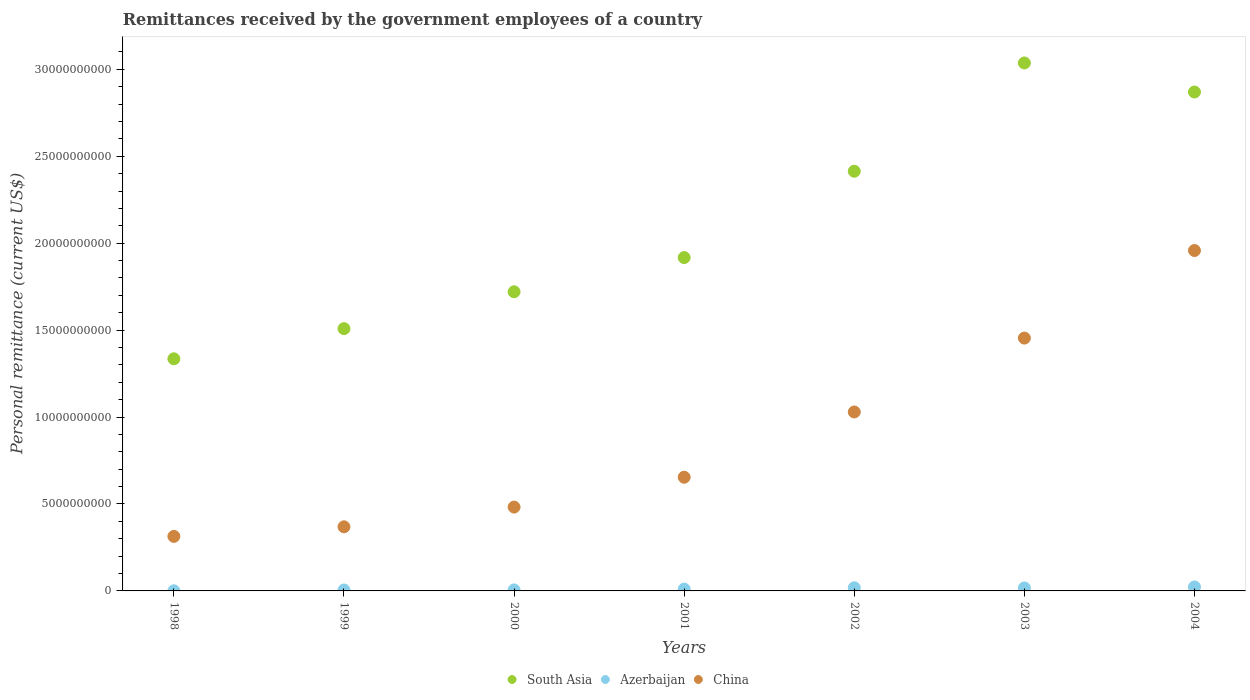How many different coloured dotlines are there?
Your answer should be very brief. 3. Is the number of dotlines equal to the number of legend labels?
Make the answer very short. Yes. What is the remittances received by the government employees in China in 1998?
Offer a terse response. 3.14e+09. Across all years, what is the maximum remittances received by the government employees in China?
Your response must be concise. 1.96e+1. Across all years, what is the minimum remittances received by the government employees in China?
Offer a terse response. 3.14e+09. In which year was the remittances received by the government employees in South Asia maximum?
Give a very brief answer. 2003. What is the total remittances received by the government employees in Azerbaijan in the graph?
Provide a short and direct response. 8.02e+08. What is the difference between the remittances received by the government employees in Azerbaijan in 1999 and that in 2004?
Give a very brief answer. -1.73e+08. What is the difference between the remittances received by the government employees in South Asia in 2003 and the remittances received by the government employees in Azerbaijan in 2000?
Keep it short and to the point. 3.03e+1. What is the average remittances received by the government employees in China per year?
Make the answer very short. 8.94e+09. In the year 2001, what is the difference between the remittances received by the government employees in Azerbaijan and remittances received by the government employees in China?
Provide a short and direct response. -6.43e+09. What is the ratio of the remittances received by the government employees in Azerbaijan in 1998 to that in 1999?
Your response must be concise. 0.12. Is the remittances received by the government employees in Azerbaijan in 2002 less than that in 2004?
Your answer should be very brief. Yes. What is the difference between the highest and the second highest remittances received by the government employees in China?
Your response must be concise. 5.04e+09. What is the difference between the highest and the lowest remittances received by the government employees in Azerbaijan?
Offer a very short reply. 2.21e+08. In how many years, is the remittances received by the government employees in South Asia greater than the average remittances received by the government employees in South Asia taken over all years?
Ensure brevity in your answer.  3. Is the remittances received by the government employees in China strictly less than the remittances received by the government employees in Azerbaijan over the years?
Offer a very short reply. No. How many dotlines are there?
Provide a succinct answer. 3. How many years are there in the graph?
Your response must be concise. 7. What is the difference between two consecutive major ticks on the Y-axis?
Provide a succinct answer. 5.00e+09. Does the graph contain grids?
Make the answer very short. No. Where does the legend appear in the graph?
Offer a very short reply. Bottom center. How many legend labels are there?
Provide a short and direct response. 3. How are the legend labels stacked?
Offer a very short reply. Horizontal. What is the title of the graph?
Keep it short and to the point. Remittances received by the government employees of a country. What is the label or title of the Y-axis?
Offer a very short reply. Personal remittance (current US$). What is the Personal remittance (current US$) in South Asia in 1998?
Give a very brief answer. 1.34e+1. What is the Personal remittance (current US$) in Azerbaijan in 1998?
Your answer should be very brief. 6.29e+06. What is the Personal remittance (current US$) of China in 1998?
Offer a terse response. 3.14e+09. What is the Personal remittance (current US$) of South Asia in 1999?
Offer a very short reply. 1.51e+1. What is the Personal remittance (current US$) of Azerbaijan in 1999?
Offer a very short reply. 5.45e+07. What is the Personal remittance (current US$) in China in 1999?
Your answer should be very brief. 3.69e+09. What is the Personal remittance (current US$) of South Asia in 2000?
Offer a very short reply. 1.72e+1. What is the Personal remittance (current US$) of Azerbaijan in 2000?
Make the answer very short. 5.71e+07. What is the Personal remittance (current US$) in China in 2000?
Provide a succinct answer. 4.82e+09. What is the Personal remittance (current US$) in South Asia in 2001?
Offer a very short reply. 1.92e+1. What is the Personal remittance (current US$) in Azerbaijan in 2001?
Give a very brief answer. 1.04e+08. What is the Personal remittance (current US$) of China in 2001?
Your answer should be compact. 6.54e+09. What is the Personal remittance (current US$) of South Asia in 2002?
Make the answer very short. 2.41e+1. What is the Personal remittance (current US$) of Azerbaijan in 2002?
Make the answer very short. 1.82e+08. What is the Personal remittance (current US$) of China in 2002?
Ensure brevity in your answer.  1.03e+1. What is the Personal remittance (current US$) of South Asia in 2003?
Make the answer very short. 3.04e+1. What is the Personal remittance (current US$) in Azerbaijan in 2003?
Provide a succinct answer. 1.71e+08. What is the Personal remittance (current US$) in China in 2003?
Provide a succinct answer. 1.45e+1. What is the Personal remittance (current US$) in South Asia in 2004?
Your answer should be very brief. 2.87e+1. What is the Personal remittance (current US$) of Azerbaijan in 2004?
Give a very brief answer. 2.28e+08. What is the Personal remittance (current US$) of China in 2004?
Your answer should be very brief. 1.96e+1. Across all years, what is the maximum Personal remittance (current US$) in South Asia?
Offer a terse response. 3.04e+1. Across all years, what is the maximum Personal remittance (current US$) in Azerbaijan?
Provide a succinct answer. 2.28e+08. Across all years, what is the maximum Personal remittance (current US$) of China?
Keep it short and to the point. 1.96e+1. Across all years, what is the minimum Personal remittance (current US$) in South Asia?
Ensure brevity in your answer.  1.34e+1. Across all years, what is the minimum Personal remittance (current US$) of Azerbaijan?
Offer a terse response. 6.29e+06. Across all years, what is the minimum Personal remittance (current US$) in China?
Provide a succinct answer. 3.14e+09. What is the total Personal remittance (current US$) of South Asia in the graph?
Offer a very short reply. 1.48e+11. What is the total Personal remittance (current US$) in Azerbaijan in the graph?
Keep it short and to the point. 8.02e+08. What is the total Personal remittance (current US$) in China in the graph?
Offer a terse response. 6.26e+1. What is the difference between the Personal remittance (current US$) in South Asia in 1998 and that in 1999?
Make the answer very short. -1.73e+09. What is the difference between the Personal remittance (current US$) in Azerbaijan in 1998 and that in 1999?
Make the answer very short. -4.82e+07. What is the difference between the Personal remittance (current US$) in China in 1998 and that in 1999?
Give a very brief answer. -5.50e+08. What is the difference between the Personal remittance (current US$) in South Asia in 1998 and that in 2000?
Your answer should be very brief. -3.85e+09. What is the difference between the Personal remittance (current US$) in Azerbaijan in 1998 and that in 2000?
Ensure brevity in your answer.  -5.08e+07. What is the difference between the Personal remittance (current US$) in China in 1998 and that in 2000?
Offer a terse response. -1.69e+09. What is the difference between the Personal remittance (current US$) of South Asia in 1998 and that in 2001?
Make the answer very short. -5.82e+09. What is the difference between the Personal remittance (current US$) of Azerbaijan in 1998 and that in 2001?
Your response must be concise. -9.78e+07. What is the difference between the Personal remittance (current US$) in China in 1998 and that in 2001?
Provide a short and direct response. -3.40e+09. What is the difference between the Personal remittance (current US$) of South Asia in 1998 and that in 2002?
Keep it short and to the point. -1.08e+1. What is the difference between the Personal remittance (current US$) of Azerbaijan in 1998 and that in 2002?
Give a very brief answer. -1.75e+08. What is the difference between the Personal remittance (current US$) in China in 1998 and that in 2002?
Ensure brevity in your answer.  -7.16e+09. What is the difference between the Personal remittance (current US$) of South Asia in 1998 and that in 2003?
Provide a succinct answer. -1.70e+1. What is the difference between the Personal remittance (current US$) of Azerbaijan in 1998 and that in 2003?
Keep it short and to the point. -1.65e+08. What is the difference between the Personal remittance (current US$) in China in 1998 and that in 2003?
Your answer should be very brief. -1.14e+1. What is the difference between the Personal remittance (current US$) of South Asia in 1998 and that in 2004?
Ensure brevity in your answer.  -1.53e+1. What is the difference between the Personal remittance (current US$) in Azerbaijan in 1998 and that in 2004?
Offer a terse response. -2.21e+08. What is the difference between the Personal remittance (current US$) in China in 1998 and that in 2004?
Offer a very short reply. -1.64e+1. What is the difference between the Personal remittance (current US$) in South Asia in 1999 and that in 2000?
Your response must be concise. -2.12e+09. What is the difference between the Personal remittance (current US$) of Azerbaijan in 1999 and that in 2000?
Provide a short and direct response. -2.64e+06. What is the difference between the Personal remittance (current US$) of China in 1999 and that in 2000?
Make the answer very short. -1.14e+09. What is the difference between the Personal remittance (current US$) of South Asia in 1999 and that in 2001?
Your response must be concise. -4.09e+09. What is the difference between the Personal remittance (current US$) in Azerbaijan in 1999 and that in 2001?
Your answer should be very brief. -4.96e+07. What is the difference between the Personal remittance (current US$) of China in 1999 and that in 2001?
Make the answer very short. -2.85e+09. What is the difference between the Personal remittance (current US$) of South Asia in 1999 and that in 2002?
Your answer should be very brief. -9.05e+09. What is the difference between the Personal remittance (current US$) in Azerbaijan in 1999 and that in 2002?
Keep it short and to the point. -1.27e+08. What is the difference between the Personal remittance (current US$) in China in 1999 and that in 2002?
Ensure brevity in your answer.  -6.61e+09. What is the difference between the Personal remittance (current US$) of South Asia in 1999 and that in 2003?
Keep it short and to the point. -1.53e+1. What is the difference between the Personal remittance (current US$) of Azerbaijan in 1999 and that in 2003?
Make the answer very short. -1.16e+08. What is the difference between the Personal remittance (current US$) of China in 1999 and that in 2003?
Give a very brief answer. -1.09e+1. What is the difference between the Personal remittance (current US$) of South Asia in 1999 and that in 2004?
Provide a succinct answer. -1.36e+1. What is the difference between the Personal remittance (current US$) in Azerbaijan in 1999 and that in 2004?
Make the answer very short. -1.73e+08. What is the difference between the Personal remittance (current US$) of China in 1999 and that in 2004?
Offer a terse response. -1.59e+1. What is the difference between the Personal remittance (current US$) of South Asia in 2000 and that in 2001?
Ensure brevity in your answer.  -1.97e+09. What is the difference between the Personal remittance (current US$) of Azerbaijan in 2000 and that in 2001?
Offer a terse response. -4.70e+07. What is the difference between the Personal remittance (current US$) in China in 2000 and that in 2001?
Provide a succinct answer. -1.72e+09. What is the difference between the Personal remittance (current US$) of South Asia in 2000 and that in 2002?
Ensure brevity in your answer.  -6.93e+09. What is the difference between the Personal remittance (current US$) of Azerbaijan in 2000 and that in 2002?
Your response must be concise. -1.25e+08. What is the difference between the Personal remittance (current US$) in China in 2000 and that in 2002?
Keep it short and to the point. -5.47e+09. What is the difference between the Personal remittance (current US$) in South Asia in 2000 and that in 2003?
Your answer should be compact. -1.32e+1. What is the difference between the Personal remittance (current US$) in Azerbaijan in 2000 and that in 2003?
Give a very brief answer. -1.14e+08. What is the difference between the Personal remittance (current US$) in China in 2000 and that in 2003?
Keep it short and to the point. -9.72e+09. What is the difference between the Personal remittance (current US$) of South Asia in 2000 and that in 2004?
Provide a short and direct response. -1.15e+1. What is the difference between the Personal remittance (current US$) of Azerbaijan in 2000 and that in 2004?
Offer a very short reply. -1.70e+08. What is the difference between the Personal remittance (current US$) in China in 2000 and that in 2004?
Offer a very short reply. -1.48e+1. What is the difference between the Personal remittance (current US$) in South Asia in 2001 and that in 2002?
Offer a very short reply. -4.97e+09. What is the difference between the Personal remittance (current US$) in Azerbaijan in 2001 and that in 2002?
Keep it short and to the point. -7.76e+07. What is the difference between the Personal remittance (current US$) of China in 2001 and that in 2002?
Offer a very short reply. -3.75e+09. What is the difference between the Personal remittance (current US$) in South Asia in 2001 and that in 2003?
Give a very brief answer. -1.12e+1. What is the difference between the Personal remittance (current US$) in Azerbaijan in 2001 and that in 2003?
Your answer should be compact. -6.68e+07. What is the difference between the Personal remittance (current US$) in China in 2001 and that in 2003?
Make the answer very short. -8.00e+09. What is the difference between the Personal remittance (current US$) of South Asia in 2001 and that in 2004?
Your answer should be very brief. -9.52e+09. What is the difference between the Personal remittance (current US$) in Azerbaijan in 2001 and that in 2004?
Your response must be concise. -1.23e+08. What is the difference between the Personal remittance (current US$) of China in 2001 and that in 2004?
Provide a succinct answer. -1.30e+1. What is the difference between the Personal remittance (current US$) of South Asia in 2002 and that in 2003?
Make the answer very short. -6.23e+09. What is the difference between the Personal remittance (current US$) in Azerbaijan in 2002 and that in 2003?
Ensure brevity in your answer.  1.08e+07. What is the difference between the Personal remittance (current US$) of China in 2002 and that in 2003?
Ensure brevity in your answer.  -4.25e+09. What is the difference between the Personal remittance (current US$) of South Asia in 2002 and that in 2004?
Offer a very short reply. -4.56e+09. What is the difference between the Personal remittance (current US$) in Azerbaijan in 2002 and that in 2004?
Provide a succinct answer. -4.59e+07. What is the difference between the Personal remittance (current US$) of China in 2002 and that in 2004?
Provide a short and direct response. -9.29e+09. What is the difference between the Personal remittance (current US$) of South Asia in 2003 and that in 2004?
Give a very brief answer. 1.67e+09. What is the difference between the Personal remittance (current US$) in Azerbaijan in 2003 and that in 2004?
Keep it short and to the point. -5.66e+07. What is the difference between the Personal remittance (current US$) in China in 2003 and that in 2004?
Make the answer very short. -5.04e+09. What is the difference between the Personal remittance (current US$) of South Asia in 1998 and the Personal remittance (current US$) of Azerbaijan in 1999?
Offer a very short reply. 1.33e+1. What is the difference between the Personal remittance (current US$) in South Asia in 1998 and the Personal remittance (current US$) in China in 1999?
Your answer should be compact. 9.66e+09. What is the difference between the Personal remittance (current US$) of Azerbaijan in 1998 and the Personal remittance (current US$) of China in 1999?
Offer a terse response. -3.68e+09. What is the difference between the Personal remittance (current US$) in South Asia in 1998 and the Personal remittance (current US$) in Azerbaijan in 2000?
Offer a terse response. 1.33e+1. What is the difference between the Personal remittance (current US$) in South Asia in 1998 and the Personal remittance (current US$) in China in 2000?
Your answer should be very brief. 8.53e+09. What is the difference between the Personal remittance (current US$) of Azerbaijan in 1998 and the Personal remittance (current US$) of China in 2000?
Give a very brief answer. -4.82e+09. What is the difference between the Personal remittance (current US$) in South Asia in 1998 and the Personal remittance (current US$) in Azerbaijan in 2001?
Offer a terse response. 1.32e+1. What is the difference between the Personal remittance (current US$) of South Asia in 1998 and the Personal remittance (current US$) of China in 2001?
Give a very brief answer. 6.81e+09. What is the difference between the Personal remittance (current US$) of Azerbaijan in 1998 and the Personal remittance (current US$) of China in 2001?
Ensure brevity in your answer.  -6.53e+09. What is the difference between the Personal remittance (current US$) of South Asia in 1998 and the Personal remittance (current US$) of Azerbaijan in 2002?
Keep it short and to the point. 1.32e+1. What is the difference between the Personal remittance (current US$) of South Asia in 1998 and the Personal remittance (current US$) of China in 2002?
Offer a very short reply. 3.06e+09. What is the difference between the Personal remittance (current US$) of Azerbaijan in 1998 and the Personal remittance (current US$) of China in 2002?
Keep it short and to the point. -1.03e+1. What is the difference between the Personal remittance (current US$) in South Asia in 1998 and the Personal remittance (current US$) in Azerbaijan in 2003?
Ensure brevity in your answer.  1.32e+1. What is the difference between the Personal remittance (current US$) in South Asia in 1998 and the Personal remittance (current US$) in China in 2003?
Your answer should be compact. -1.19e+09. What is the difference between the Personal remittance (current US$) of Azerbaijan in 1998 and the Personal remittance (current US$) of China in 2003?
Provide a succinct answer. -1.45e+1. What is the difference between the Personal remittance (current US$) in South Asia in 1998 and the Personal remittance (current US$) in Azerbaijan in 2004?
Offer a terse response. 1.31e+1. What is the difference between the Personal remittance (current US$) of South Asia in 1998 and the Personal remittance (current US$) of China in 2004?
Your answer should be compact. -6.23e+09. What is the difference between the Personal remittance (current US$) in Azerbaijan in 1998 and the Personal remittance (current US$) in China in 2004?
Your response must be concise. -1.96e+1. What is the difference between the Personal remittance (current US$) of South Asia in 1999 and the Personal remittance (current US$) of Azerbaijan in 2000?
Your response must be concise. 1.50e+1. What is the difference between the Personal remittance (current US$) of South Asia in 1999 and the Personal remittance (current US$) of China in 2000?
Offer a terse response. 1.03e+1. What is the difference between the Personal remittance (current US$) of Azerbaijan in 1999 and the Personal remittance (current US$) of China in 2000?
Your answer should be compact. -4.77e+09. What is the difference between the Personal remittance (current US$) in South Asia in 1999 and the Personal remittance (current US$) in Azerbaijan in 2001?
Provide a succinct answer. 1.50e+1. What is the difference between the Personal remittance (current US$) in South Asia in 1999 and the Personal remittance (current US$) in China in 2001?
Provide a short and direct response. 8.55e+09. What is the difference between the Personal remittance (current US$) of Azerbaijan in 1999 and the Personal remittance (current US$) of China in 2001?
Offer a very short reply. -6.48e+09. What is the difference between the Personal remittance (current US$) of South Asia in 1999 and the Personal remittance (current US$) of Azerbaijan in 2002?
Make the answer very short. 1.49e+1. What is the difference between the Personal remittance (current US$) of South Asia in 1999 and the Personal remittance (current US$) of China in 2002?
Make the answer very short. 4.79e+09. What is the difference between the Personal remittance (current US$) in Azerbaijan in 1999 and the Personal remittance (current US$) in China in 2002?
Your answer should be very brief. -1.02e+1. What is the difference between the Personal remittance (current US$) in South Asia in 1999 and the Personal remittance (current US$) in Azerbaijan in 2003?
Keep it short and to the point. 1.49e+1. What is the difference between the Personal remittance (current US$) in South Asia in 1999 and the Personal remittance (current US$) in China in 2003?
Keep it short and to the point. 5.43e+08. What is the difference between the Personal remittance (current US$) in Azerbaijan in 1999 and the Personal remittance (current US$) in China in 2003?
Keep it short and to the point. -1.45e+1. What is the difference between the Personal remittance (current US$) of South Asia in 1999 and the Personal remittance (current US$) of Azerbaijan in 2004?
Ensure brevity in your answer.  1.49e+1. What is the difference between the Personal remittance (current US$) of South Asia in 1999 and the Personal remittance (current US$) of China in 2004?
Ensure brevity in your answer.  -4.49e+09. What is the difference between the Personal remittance (current US$) in Azerbaijan in 1999 and the Personal remittance (current US$) in China in 2004?
Offer a very short reply. -1.95e+1. What is the difference between the Personal remittance (current US$) in South Asia in 2000 and the Personal remittance (current US$) in Azerbaijan in 2001?
Your answer should be very brief. 1.71e+1. What is the difference between the Personal remittance (current US$) of South Asia in 2000 and the Personal remittance (current US$) of China in 2001?
Your answer should be very brief. 1.07e+1. What is the difference between the Personal remittance (current US$) of Azerbaijan in 2000 and the Personal remittance (current US$) of China in 2001?
Provide a succinct answer. -6.48e+09. What is the difference between the Personal remittance (current US$) in South Asia in 2000 and the Personal remittance (current US$) in Azerbaijan in 2002?
Ensure brevity in your answer.  1.70e+1. What is the difference between the Personal remittance (current US$) in South Asia in 2000 and the Personal remittance (current US$) in China in 2002?
Provide a short and direct response. 6.91e+09. What is the difference between the Personal remittance (current US$) of Azerbaijan in 2000 and the Personal remittance (current US$) of China in 2002?
Provide a succinct answer. -1.02e+1. What is the difference between the Personal remittance (current US$) in South Asia in 2000 and the Personal remittance (current US$) in Azerbaijan in 2003?
Ensure brevity in your answer.  1.70e+1. What is the difference between the Personal remittance (current US$) of South Asia in 2000 and the Personal remittance (current US$) of China in 2003?
Give a very brief answer. 2.66e+09. What is the difference between the Personal remittance (current US$) of Azerbaijan in 2000 and the Personal remittance (current US$) of China in 2003?
Provide a succinct answer. -1.45e+1. What is the difference between the Personal remittance (current US$) in South Asia in 2000 and the Personal remittance (current US$) in Azerbaijan in 2004?
Offer a very short reply. 1.70e+1. What is the difference between the Personal remittance (current US$) in South Asia in 2000 and the Personal remittance (current US$) in China in 2004?
Make the answer very short. -2.37e+09. What is the difference between the Personal remittance (current US$) in Azerbaijan in 2000 and the Personal remittance (current US$) in China in 2004?
Make the answer very short. -1.95e+1. What is the difference between the Personal remittance (current US$) in South Asia in 2001 and the Personal remittance (current US$) in Azerbaijan in 2002?
Provide a succinct answer. 1.90e+1. What is the difference between the Personal remittance (current US$) of South Asia in 2001 and the Personal remittance (current US$) of China in 2002?
Your response must be concise. 8.88e+09. What is the difference between the Personal remittance (current US$) in Azerbaijan in 2001 and the Personal remittance (current US$) in China in 2002?
Your answer should be compact. -1.02e+1. What is the difference between the Personal remittance (current US$) of South Asia in 2001 and the Personal remittance (current US$) of Azerbaijan in 2003?
Your response must be concise. 1.90e+1. What is the difference between the Personal remittance (current US$) in South Asia in 2001 and the Personal remittance (current US$) in China in 2003?
Provide a succinct answer. 4.63e+09. What is the difference between the Personal remittance (current US$) in Azerbaijan in 2001 and the Personal remittance (current US$) in China in 2003?
Offer a terse response. -1.44e+1. What is the difference between the Personal remittance (current US$) in South Asia in 2001 and the Personal remittance (current US$) in Azerbaijan in 2004?
Keep it short and to the point. 1.89e+1. What is the difference between the Personal remittance (current US$) in South Asia in 2001 and the Personal remittance (current US$) in China in 2004?
Keep it short and to the point. -4.06e+08. What is the difference between the Personal remittance (current US$) of Azerbaijan in 2001 and the Personal remittance (current US$) of China in 2004?
Provide a succinct answer. -1.95e+1. What is the difference between the Personal remittance (current US$) in South Asia in 2002 and the Personal remittance (current US$) in Azerbaijan in 2003?
Offer a terse response. 2.40e+1. What is the difference between the Personal remittance (current US$) of South Asia in 2002 and the Personal remittance (current US$) of China in 2003?
Make the answer very short. 9.59e+09. What is the difference between the Personal remittance (current US$) in Azerbaijan in 2002 and the Personal remittance (current US$) in China in 2003?
Your answer should be very brief. -1.44e+1. What is the difference between the Personal remittance (current US$) in South Asia in 2002 and the Personal remittance (current US$) in Azerbaijan in 2004?
Ensure brevity in your answer.  2.39e+1. What is the difference between the Personal remittance (current US$) in South Asia in 2002 and the Personal remittance (current US$) in China in 2004?
Your answer should be compact. 4.56e+09. What is the difference between the Personal remittance (current US$) of Azerbaijan in 2002 and the Personal remittance (current US$) of China in 2004?
Your answer should be compact. -1.94e+1. What is the difference between the Personal remittance (current US$) in South Asia in 2003 and the Personal remittance (current US$) in Azerbaijan in 2004?
Make the answer very short. 3.01e+1. What is the difference between the Personal remittance (current US$) in South Asia in 2003 and the Personal remittance (current US$) in China in 2004?
Your response must be concise. 1.08e+1. What is the difference between the Personal remittance (current US$) in Azerbaijan in 2003 and the Personal remittance (current US$) in China in 2004?
Your answer should be very brief. -1.94e+1. What is the average Personal remittance (current US$) in South Asia per year?
Provide a short and direct response. 2.11e+1. What is the average Personal remittance (current US$) in Azerbaijan per year?
Ensure brevity in your answer.  1.15e+08. What is the average Personal remittance (current US$) of China per year?
Provide a short and direct response. 8.94e+09. In the year 1998, what is the difference between the Personal remittance (current US$) in South Asia and Personal remittance (current US$) in Azerbaijan?
Provide a succinct answer. 1.33e+1. In the year 1998, what is the difference between the Personal remittance (current US$) in South Asia and Personal remittance (current US$) in China?
Keep it short and to the point. 1.02e+1. In the year 1998, what is the difference between the Personal remittance (current US$) in Azerbaijan and Personal remittance (current US$) in China?
Offer a terse response. -3.13e+09. In the year 1999, what is the difference between the Personal remittance (current US$) in South Asia and Personal remittance (current US$) in Azerbaijan?
Provide a succinct answer. 1.50e+1. In the year 1999, what is the difference between the Personal remittance (current US$) in South Asia and Personal remittance (current US$) in China?
Ensure brevity in your answer.  1.14e+1. In the year 1999, what is the difference between the Personal remittance (current US$) in Azerbaijan and Personal remittance (current US$) in China?
Provide a succinct answer. -3.63e+09. In the year 2000, what is the difference between the Personal remittance (current US$) of South Asia and Personal remittance (current US$) of Azerbaijan?
Give a very brief answer. 1.71e+1. In the year 2000, what is the difference between the Personal remittance (current US$) in South Asia and Personal remittance (current US$) in China?
Your answer should be compact. 1.24e+1. In the year 2000, what is the difference between the Personal remittance (current US$) in Azerbaijan and Personal remittance (current US$) in China?
Your answer should be compact. -4.76e+09. In the year 2001, what is the difference between the Personal remittance (current US$) in South Asia and Personal remittance (current US$) in Azerbaijan?
Ensure brevity in your answer.  1.91e+1. In the year 2001, what is the difference between the Personal remittance (current US$) in South Asia and Personal remittance (current US$) in China?
Make the answer very short. 1.26e+1. In the year 2001, what is the difference between the Personal remittance (current US$) in Azerbaijan and Personal remittance (current US$) in China?
Keep it short and to the point. -6.43e+09. In the year 2002, what is the difference between the Personal remittance (current US$) in South Asia and Personal remittance (current US$) in Azerbaijan?
Make the answer very short. 2.40e+1. In the year 2002, what is the difference between the Personal remittance (current US$) in South Asia and Personal remittance (current US$) in China?
Give a very brief answer. 1.38e+1. In the year 2002, what is the difference between the Personal remittance (current US$) in Azerbaijan and Personal remittance (current US$) in China?
Ensure brevity in your answer.  -1.01e+1. In the year 2003, what is the difference between the Personal remittance (current US$) of South Asia and Personal remittance (current US$) of Azerbaijan?
Provide a succinct answer. 3.02e+1. In the year 2003, what is the difference between the Personal remittance (current US$) of South Asia and Personal remittance (current US$) of China?
Offer a terse response. 1.58e+1. In the year 2003, what is the difference between the Personal remittance (current US$) of Azerbaijan and Personal remittance (current US$) of China?
Offer a terse response. -1.44e+1. In the year 2004, what is the difference between the Personal remittance (current US$) in South Asia and Personal remittance (current US$) in Azerbaijan?
Provide a succinct answer. 2.85e+1. In the year 2004, what is the difference between the Personal remittance (current US$) of South Asia and Personal remittance (current US$) of China?
Your answer should be compact. 9.12e+09. In the year 2004, what is the difference between the Personal remittance (current US$) in Azerbaijan and Personal remittance (current US$) in China?
Make the answer very short. -1.94e+1. What is the ratio of the Personal remittance (current US$) of South Asia in 1998 to that in 1999?
Offer a terse response. 0.89. What is the ratio of the Personal remittance (current US$) of Azerbaijan in 1998 to that in 1999?
Your response must be concise. 0.12. What is the ratio of the Personal remittance (current US$) of China in 1998 to that in 1999?
Ensure brevity in your answer.  0.85. What is the ratio of the Personal remittance (current US$) in South Asia in 1998 to that in 2000?
Give a very brief answer. 0.78. What is the ratio of the Personal remittance (current US$) in Azerbaijan in 1998 to that in 2000?
Your answer should be compact. 0.11. What is the ratio of the Personal remittance (current US$) in China in 1998 to that in 2000?
Your answer should be compact. 0.65. What is the ratio of the Personal remittance (current US$) of South Asia in 1998 to that in 2001?
Keep it short and to the point. 0.7. What is the ratio of the Personal remittance (current US$) in Azerbaijan in 1998 to that in 2001?
Make the answer very short. 0.06. What is the ratio of the Personal remittance (current US$) in China in 1998 to that in 2001?
Offer a very short reply. 0.48. What is the ratio of the Personal remittance (current US$) of South Asia in 1998 to that in 2002?
Offer a terse response. 0.55. What is the ratio of the Personal remittance (current US$) of Azerbaijan in 1998 to that in 2002?
Ensure brevity in your answer.  0.03. What is the ratio of the Personal remittance (current US$) in China in 1998 to that in 2002?
Provide a succinct answer. 0.3. What is the ratio of the Personal remittance (current US$) of South Asia in 1998 to that in 2003?
Keep it short and to the point. 0.44. What is the ratio of the Personal remittance (current US$) in Azerbaijan in 1998 to that in 2003?
Give a very brief answer. 0.04. What is the ratio of the Personal remittance (current US$) of China in 1998 to that in 2003?
Ensure brevity in your answer.  0.22. What is the ratio of the Personal remittance (current US$) in South Asia in 1998 to that in 2004?
Your answer should be compact. 0.47. What is the ratio of the Personal remittance (current US$) of Azerbaijan in 1998 to that in 2004?
Your answer should be compact. 0.03. What is the ratio of the Personal remittance (current US$) in China in 1998 to that in 2004?
Provide a short and direct response. 0.16. What is the ratio of the Personal remittance (current US$) in South Asia in 1999 to that in 2000?
Offer a terse response. 0.88. What is the ratio of the Personal remittance (current US$) of Azerbaijan in 1999 to that in 2000?
Your answer should be very brief. 0.95. What is the ratio of the Personal remittance (current US$) of China in 1999 to that in 2000?
Keep it short and to the point. 0.76. What is the ratio of the Personal remittance (current US$) of South Asia in 1999 to that in 2001?
Ensure brevity in your answer.  0.79. What is the ratio of the Personal remittance (current US$) of Azerbaijan in 1999 to that in 2001?
Your answer should be compact. 0.52. What is the ratio of the Personal remittance (current US$) of China in 1999 to that in 2001?
Your answer should be very brief. 0.56. What is the ratio of the Personal remittance (current US$) in South Asia in 1999 to that in 2002?
Your response must be concise. 0.62. What is the ratio of the Personal remittance (current US$) of Azerbaijan in 1999 to that in 2002?
Your answer should be compact. 0.3. What is the ratio of the Personal remittance (current US$) in China in 1999 to that in 2002?
Provide a succinct answer. 0.36. What is the ratio of the Personal remittance (current US$) in South Asia in 1999 to that in 2003?
Provide a short and direct response. 0.5. What is the ratio of the Personal remittance (current US$) in Azerbaijan in 1999 to that in 2003?
Your response must be concise. 0.32. What is the ratio of the Personal remittance (current US$) in China in 1999 to that in 2003?
Your answer should be compact. 0.25. What is the ratio of the Personal remittance (current US$) of South Asia in 1999 to that in 2004?
Provide a short and direct response. 0.53. What is the ratio of the Personal remittance (current US$) of Azerbaijan in 1999 to that in 2004?
Your answer should be compact. 0.24. What is the ratio of the Personal remittance (current US$) in China in 1999 to that in 2004?
Provide a succinct answer. 0.19. What is the ratio of the Personal remittance (current US$) in South Asia in 2000 to that in 2001?
Offer a very short reply. 0.9. What is the ratio of the Personal remittance (current US$) in Azerbaijan in 2000 to that in 2001?
Your answer should be compact. 0.55. What is the ratio of the Personal remittance (current US$) in China in 2000 to that in 2001?
Ensure brevity in your answer.  0.74. What is the ratio of the Personal remittance (current US$) of South Asia in 2000 to that in 2002?
Provide a short and direct response. 0.71. What is the ratio of the Personal remittance (current US$) of Azerbaijan in 2000 to that in 2002?
Give a very brief answer. 0.31. What is the ratio of the Personal remittance (current US$) of China in 2000 to that in 2002?
Your answer should be very brief. 0.47. What is the ratio of the Personal remittance (current US$) of South Asia in 2000 to that in 2003?
Your response must be concise. 0.57. What is the ratio of the Personal remittance (current US$) of Azerbaijan in 2000 to that in 2003?
Your response must be concise. 0.33. What is the ratio of the Personal remittance (current US$) of China in 2000 to that in 2003?
Make the answer very short. 0.33. What is the ratio of the Personal remittance (current US$) in South Asia in 2000 to that in 2004?
Give a very brief answer. 0.6. What is the ratio of the Personal remittance (current US$) in Azerbaijan in 2000 to that in 2004?
Keep it short and to the point. 0.25. What is the ratio of the Personal remittance (current US$) in China in 2000 to that in 2004?
Keep it short and to the point. 0.25. What is the ratio of the Personal remittance (current US$) of South Asia in 2001 to that in 2002?
Give a very brief answer. 0.79. What is the ratio of the Personal remittance (current US$) in Azerbaijan in 2001 to that in 2002?
Give a very brief answer. 0.57. What is the ratio of the Personal remittance (current US$) in China in 2001 to that in 2002?
Provide a short and direct response. 0.64. What is the ratio of the Personal remittance (current US$) of South Asia in 2001 to that in 2003?
Provide a short and direct response. 0.63. What is the ratio of the Personal remittance (current US$) in Azerbaijan in 2001 to that in 2003?
Offer a very short reply. 0.61. What is the ratio of the Personal remittance (current US$) of China in 2001 to that in 2003?
Your response must be concise. 0.45. What is the ratio of the Personal remittance (current US$) of South Asia in 2001 to that in 2004?
Ensure brevity in your answer.  0.67. What is the ratio of the Personal remittance (current US$) in Azerbaijan in 2001 to that in 2004?
Keep it short and to the point. 0.46. What is the ratio of the Personal remittance (current US$) of China in 2001 to that in 2004?
Provide a succinct answer. 0.33. What is the ratio of the Personal remittance (current US$) of South Asia in 2002 to that in 2003?
Your response must be concise. 0.79. What is the ratio of the Personal remittance (current US$) of Azerbaijan in 2002 to that in 2003?
Your response must be concise. 1.06. What is the ratio of the Personal remittance (current US$) in China in 2002 to that in 2003?
Offer a very short reply. 0.71. What is the ratio of the Personal remittance (current US$) of South Asia in 2002 to that in 2004?
Your answer should be very brief. 0.84. What is the ratio of the Personal remittance (current US$) in Azerbaijan in 2002 to that in 2004?
Provide a short and direct response. 0.8. What is the ratio of the Personal remittance (current US$) of China in 2002 to that in 2004?
Your answer should be very brief. 0.53. What is the ratio of the Personal remittance (current US$) in South Asia in 2003 to that in 2004?
Offer a terse response. 1.06. What is the ratio of the Personal remittance (current US$) of Azerbaijan in 2003 to that in 2004?
Provide a succinct answer. 0.75. What is the ratio of the Personal remittance (current US$) in China in 2003 to that in 2004?
Provide a succinct answer. 0.74. What is the difference between the highest and the second highest Personal remittance (current US$) of South Asia?
Your answer should be compact. 1.67e+09. What is the difference between the highest and the second highest Personal remittance (current US$) in Azerbaijan?
Offer a terse response. 4.59e+07. What is the difference between the highest and the second highest Personal remittance (current US$) of China?
Offer a very short reply. 5.04e+09. What is the difference between the highest and the lowest Personal remittance (current US$) of South Asia?
Ensure brevity in your answer.  1.70e+1. What is the difference between the highest and the lowest Personal remittance (current US$) in Azerbaijan?
Your answer should be very brief. 2.21e+08. What is the difference between the highest and the lowest Personal remittance (current US$) of China?
Your answer should be compact. 1.64e+1. 